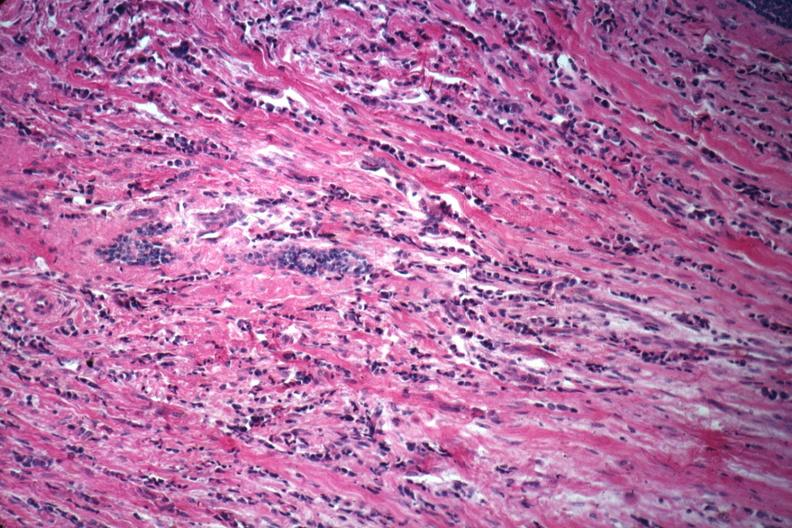s typical tuberculous exudate present?
Answer the question using a single word or phrase. No 